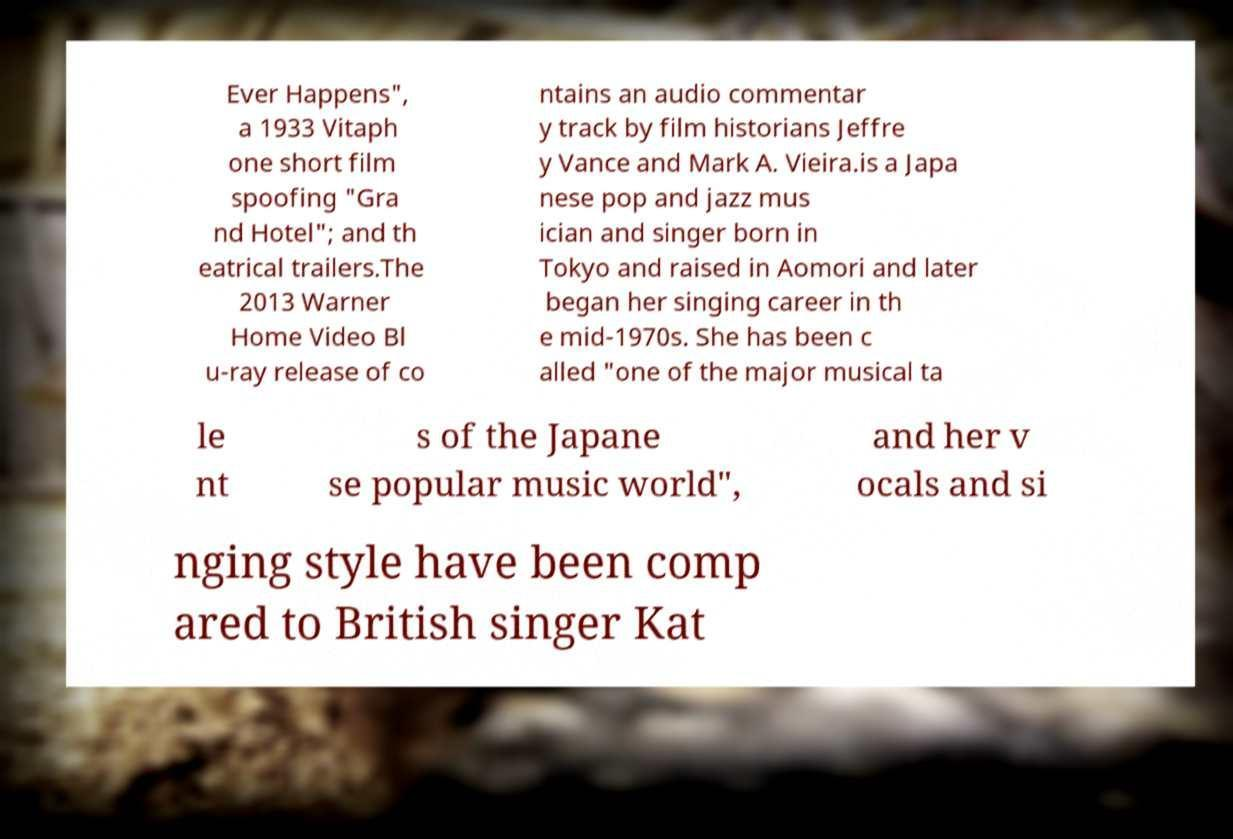What messages or text are displayed in this image? I need them in a readable, typed format. Ever Happens", a 1933 Vitaph one short film spoofing "Gra nd Hotel"; and th eatrical trailers.The 2013 Warner Home Video Bl u-ray release of co ntains an audio commentar y track by film historians Jeffre y Vance and Mark A. Vieira.is a Japa nese pop and jazz mus ician and singer born in Tokyo and raised in Aomori and later began her singing career in th e mid-1970s. She has been c alled "one of the major musical ta le nt s of the Japane se popular music world", and her v ocals and si nging style have been comp ared to British singer Kat 